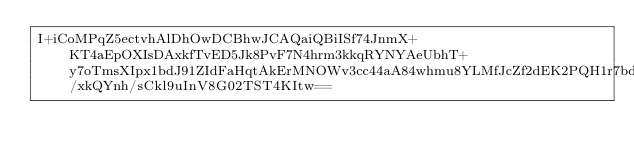<code> <loc_0><loc_0><loc_500><loc_500><_SML_>I+iCoMPqZ5ectvhAlDhOwDCBhwJCAQaiQBiISf74JnmX+KT4aEpOXIsDAxkfTvED5Jk8PvF7N4hrm3kkqRYNYAeUbhT+y7oTmsXIpx1bdJ91ZIdFaHqtAkErMNOWv3cc44aA84whmu8YLMfJcZf2dEK2PQH1r7bdIWOv5O5bcMTAJlT7Q/xkQYnh/sCkl9uInV8G02TST4KItw==</code> 